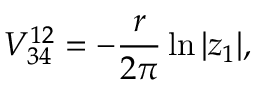Convert formula to latex. <formula><loc_0><loc_0><loc_500><loc_500>V _ { 3 4 } ^ { 1 2 } = - { \frac { r } { 2 \pi } } \ln | z _ { 1 } | ,</formula> 